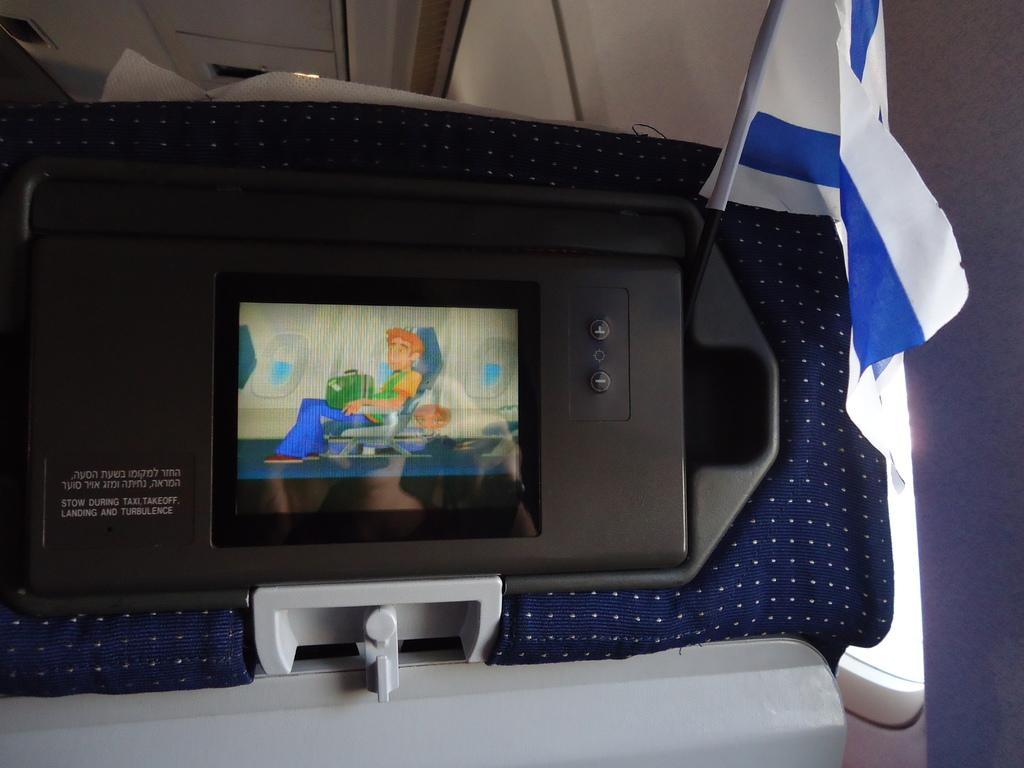What is the main object in the image? There is a screen in the image. What is being displayed on the screen? Cartoon characters are visible on the screen. Are there any words or letters in the image? Yes, there is text written in the image. What can be seen in the background of the image? There is a white and blue color flag in the image. How many cubs are playing with the pin in the image? There are no cubs or pins present in the image. 